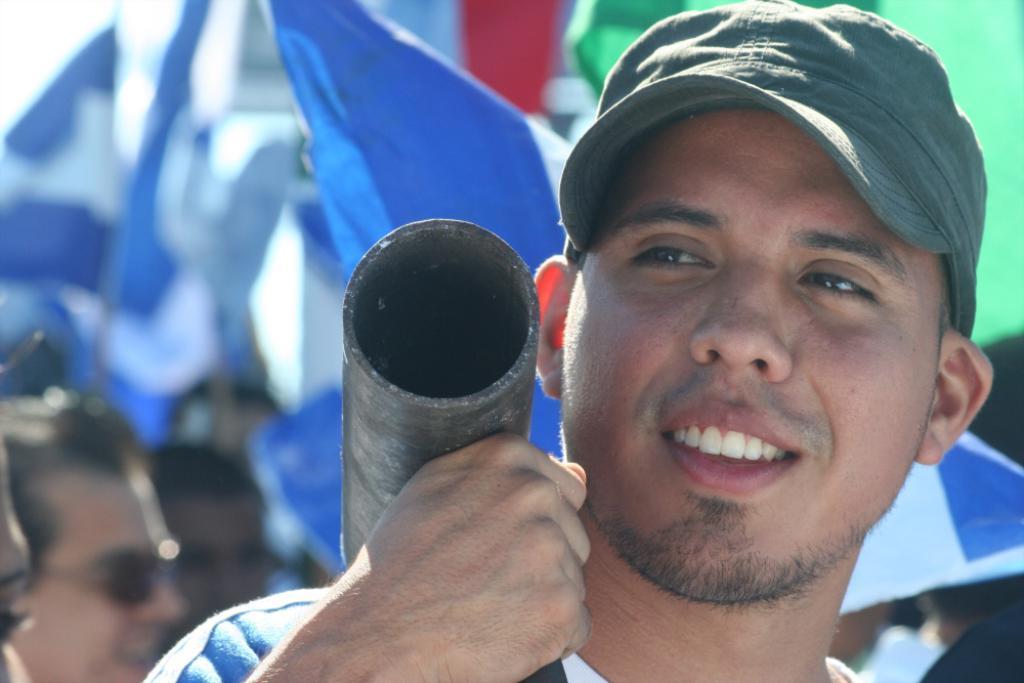In one or two sentences, can you explain what this image depicts? This picture shows few of them standing and we see a man wore cap on his head and he is holding a metal rod with his hand on the shoulder and we see flags and a man wore sunglasses on his face. 